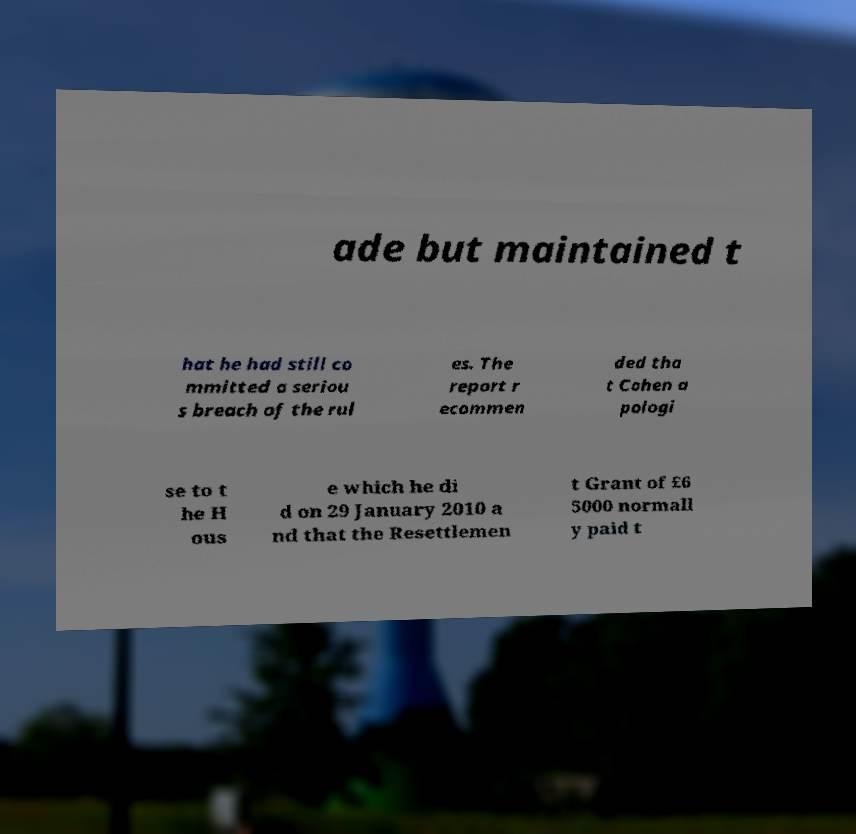Please read and relay the text visible in this image. What does it say? ade but maintained t hat he had still co mmitted a seriou s breach of the rul es. The report r ecommen ded tha t Cohen a pologi se to t he H ous e which he di d on 29 January 2010 a nd that the Resettlemen t Grant of £6 5000 normall y paid t 